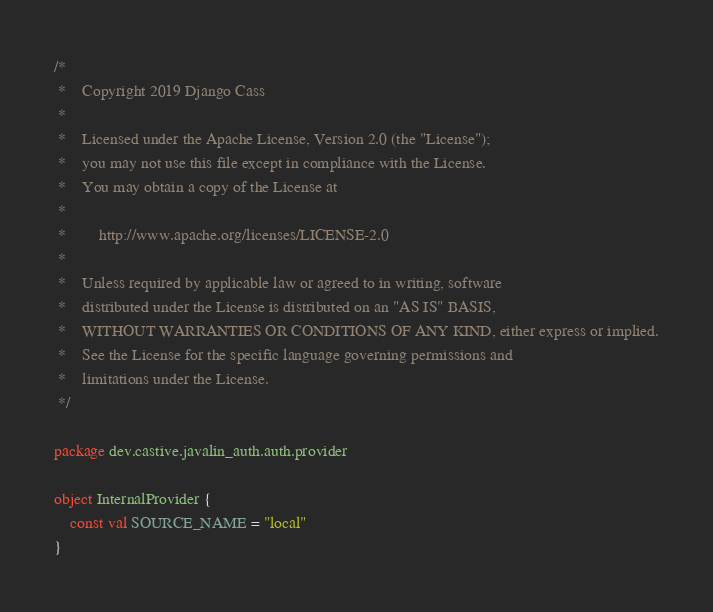<code> <loc_0><loc_0><loc_500><loc_500><_Kotlin_>/*
 *    Copyright 2019 Django Cass
 *
 *    Licensed under the Apache License, Version 2.0 (the "License");
 *    you may not use this file except in compliance with the License.
 *    You may obtain a copy of the License at
 *
 *        http://www.apache.org/licenses/LICENSE-2.0
 *
 *    Unless required by applicable law or agreed to in writing, software
 *    distributed under the License is distributed on an "AS IS" BASIS,
 *    WITHOUT WARRANTIES OR CONDITIONS OF ANY KIND, either express or implied.
 *    See the License for the specific language governing permissions and
 *    limitations under the License.
 */

package dev.castive.javalin_auth.auth.provider

object InternalProvider {
	const val SOURCE_NAME = "local"
}</code> 